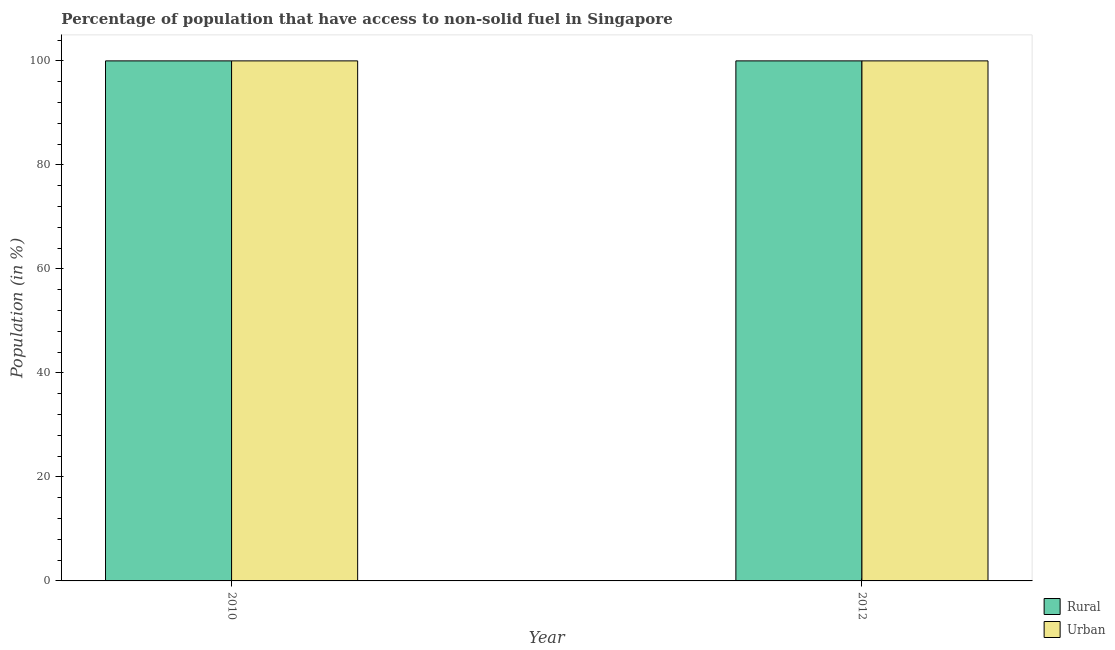How many different coloured bars are there?
Provide a short and direct response. 2. Are the number of bars per tick equal to the number of legend labels?
Keep it short and to the point. Yes. Are the number of bars on each tick of the X-axis equal?
Your answer should be very brief. Yes. How many bars are there on the 2nd tick from the left?
Keep it short and to the point. 2. How many bars are there on the 1st tick from the right?
Provide a short and direct response. 2. What is the urban population in 2010?
Your answer should be compact. 100. Across all years, what is the maximum rural population?
Give a very brief answer. 100. Across all years, what is the minimum rural population?
Offer a very short reply. 100. In which year was the urban population minimum?
Give a very brief answer. 2010. What is the total urban population in the graph?
Give a very brief answer. 200. What is the difference between the rural population in 2010 and that in 2012?
Ensure brevity in your answer.  0. What is the difference between the rural population in 2012 and the urban population in 2010?
Give a very brief answer. 0. What does the 2nd bar from the left in 2010 represents?
Give a very brief answer. Urban. What does the 1st bar from the right in 2012 represents?
Offer a terse response. Urban. How many bars are there?
Provide a succinct answer. 4. How many years are there in the graph?
Keep it short and to the point. 2. What is the difference between two consecutive major ticks on the Y-axis?
Offer a terse response. 20. Where does the legend appear in the graph?
Ensure brevity in your answer.  Bottom right. What is the title of the graph?
Provide a succinct answer. Percentage of population that have access to non-solid fuel in Singapore. Does "Commercial service exports" appear as one of the legend labels in the graph?
Your answer should be very brief. No. What is the label or title of the Y-axis?
Ensure brevity in your answer.  Population (in %). What is the Population (in %) of Urban in 2010?
Offer a terse response. 100. What is the Population (in %) of Rural in 2012?
Your answer should be compact. 100. What is the Population (in %) in Urban in 2012?
Your answer should be very brief. 100. Across all years, what is the maximum Population (in %) of Urban?
Make the answer very short. 100. Across all years, what is the minimum Population (in %) of Rural?
Keep it short and to the point. 100. Across all years, what is the minimum Population (in %) in Urban?
Give a very brief answer. 100. What is the total Population (in %) of Rural in the graph?
Offer a very short reply. 200. What is the difference between the Population (in %) in Urban in 2010 and that in 2012?
Ensure brevity in your answer.  0. What is the difference between the Population (in %) of Rural in 2010 and the Population (in %) of Urban in 2012?
Provide a succinct answer. 0. What is the ratio of the Population (in %) in Rural in 2010 to that in 2012?
Your answer should be compact. 1. What is the ratio of the Population (in %) in Urban in 2010 to that in 2012?
Your response must be concise. 1. What is the difference between the highest and the second highest Population (in %) of Rural?
Ensure brevity in your answer.  0. What is the difference between the highest and the lowest Population (in %) of Rural?
Offer a terse response. 0. 